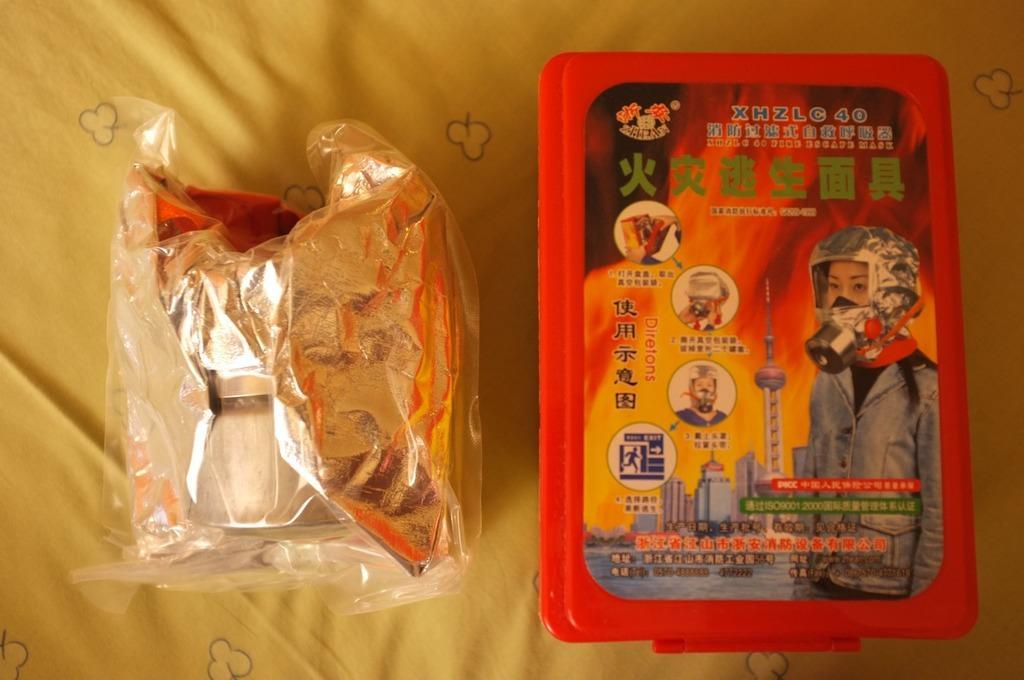How would you summarize this image in a sentence or two? In the picture we can see a yellow colored cloth on it, we can see some packet with some object in it and beside we can see a red color box with some advertisement on it. 